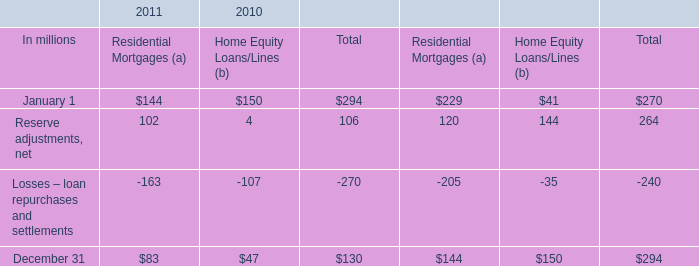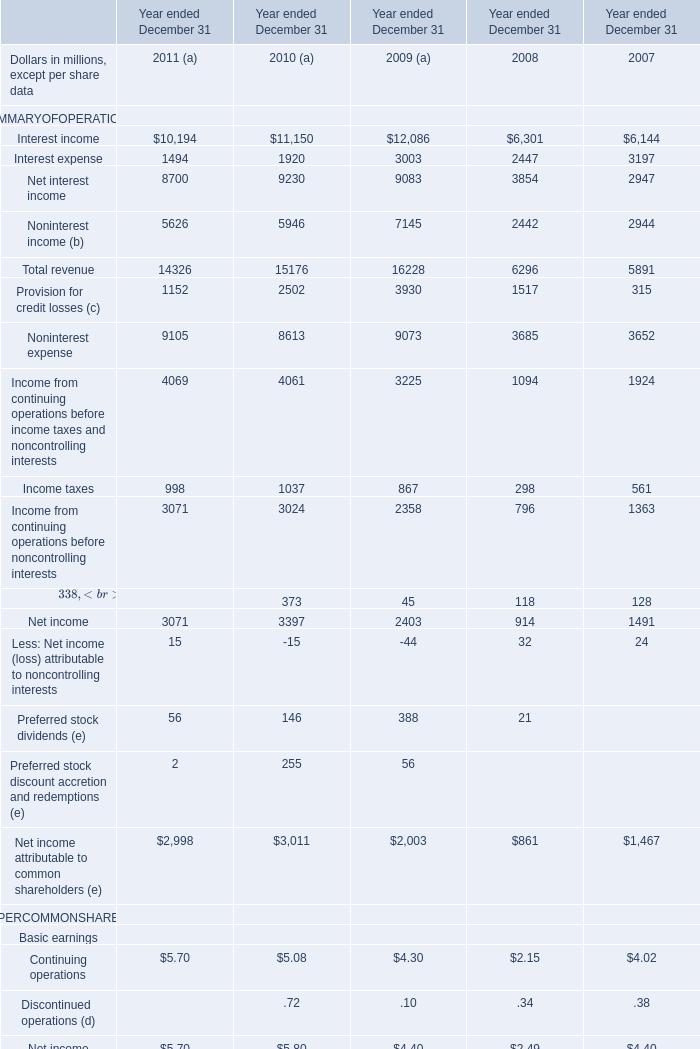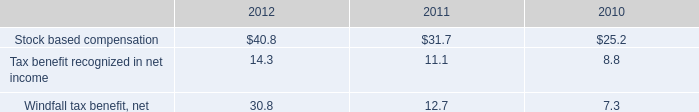what was the ratio of the the total indemnification and repurchase liability for estimated losses on indemnification and repurchase claims \\n 
Computations: (130 + 294)
Answer: 424.0. 